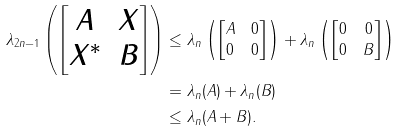<formula> <loc_0><loc_0><loc_500><loc_500>\lambda _ { 2 n - 1 } \left ( \begin{bmatrix} A & X \\ X ^ { * } & B \end{bmatrix} \right ) & \leq \lambda _ { n } \left ( \begin{bmatrix} A & 0 \\ 0 & 0 \end{bmatrix} \right ) + \lambda _ { n } \left ( \begin{bmatrix} 0 & 0 \\ 0 & B \end{bmatrix} \right ) \\ & = \lambda _ { n } ( A ) + \lambda _ { n } ( B ) \\ & \leq \lambda _ { n } ( A + B ) .</formula> 